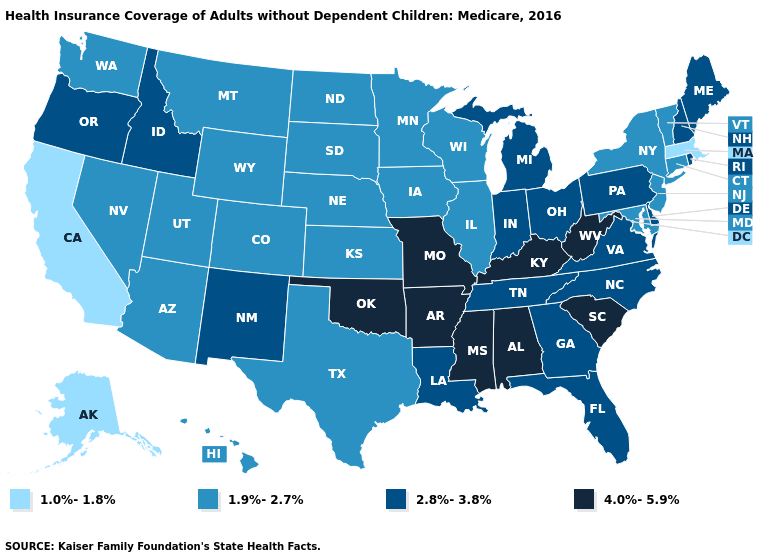Does the first symbol in the legend represent the smallest category?
Be succinct. Yes. What is the value of Mississippi?
Give a very brief answer. 4.0%-5.9%. Does Minnesota have the lowest value in the MidWest?
Keep it brief. Yes. What is the value of Connecticut?
Quick response, please. 1.9%-2.7%. Among the states that border Missouri , which have the lowest value?
Short answer required. Illinois, Iowa, Kansas, Nebraska. Name the states that have a value in the range 1.0%-1.8%?
Give a very brief answer. Alaska, California, Massachusetts. Name the states that have a value in the range 4.0%-5.9%?
Give a very brief answer. Alabama, Arkansas, Kentucky, Mississippi, Missouri, Oklahoma, South Carolina, West Virginia. Which states have the lowest value in the USA?
Give a very brief answer. Alaska, California, Massachusetts. Does Nebraska have a lower value than Alaska?
Short answer required. No. Name the states that have a value in the range 1.9%-2.7%?
Quick response, please. Arizona, Colorado, Connecticut, Hawaii, Illinois, Iowa, Kansas, Maryland, Minnesota, Montana, Nebraska, Nevada, New Jersey, New York, North Dakota, South Dakota, Texas, Utah, Vermont, Washington, Wisconsin, Wyoming. What is the value of Illinois?
Give a very brief answer. 1.9%-2.7%. What is the value of New York?
Short answer required. 1.9%-2.7%. What is the highest value in the USA?
Answer briefly. 4.0%-5.9%. Does Mississippi have the highest value in the USA?
Answer briefly. Yes. 